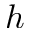Convert formula to latex. <formula><loc_0><loc_0><loc_500><loc_500>h</formula> 